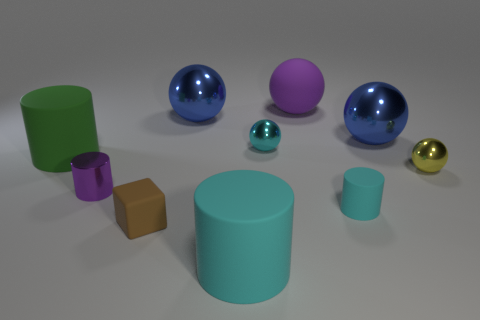Are there any cylinders that have the same color as the cube?
Keep it short and to the point. No. There is a yellow object; is its shape the same as the large object that is on the left side of the small brown matte block?
Offer a terse response. No. How many cyan objects are behind the brown matte block and in front of the cyan metal sphere?
Your answer should be compact. 1. There is another small thing that is the same shape as the yellow shiny object; what is its material?
Your answer should be very brief. Metal. There is a purple thing behind the rubber thing that is to the left of the brown block; what is its size?
Give a very brief answer. Large. Is there a tiny purple thing?
Your answer should be very brief. Yes. There is a small thing that is on the right side of the tiny matte cube and to the left of the tiny matte cylinder; what material is it?
Keep it short and to the point. Metal. Are there more big purple objects in front of the tiny cyan matte cylinder than big spheres that are on the left side of the purple cylinder?
Your answer should be compact. No. Is there a matte ball that has the same size as the metallic cylinder?
Your response must be concise. No. What is the size of the green cylinder to the left of the big blue metallic sphere to the right of the large object that is in front of the purple shiny cylinder?
Your answer should be compact. Large. 